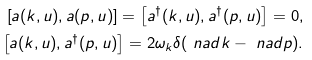<formula> <loc_0><loc_0><loc_500><loc_500>\left [ a ( k , u ) , a ( p , u ) \right ] = \left [ a ^ { \dagger } ( k , u ) , a ^ { \dagger } ( p , u ) \right ] = 0 , \\ \left [ a ( k , u ) , a ^ { \dagger } ( p , u ) \right ] = 2 \omega _ { k } \delta ( \ n a d { k } - \ n a d { p } ) .</formula> 